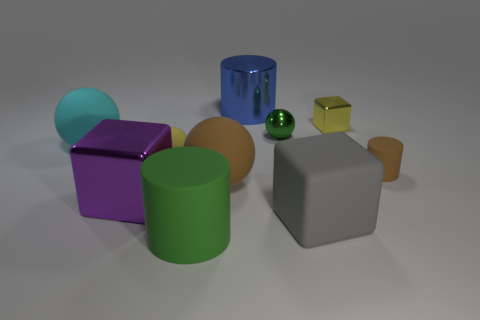Does the small metal sphere have the same color as the large cube on the left side of the blue metallic cylinder?
Offer a very short reply. No. Are there the same number of tiny yellow rubber objects that are right of the big blue object and brown rubber cylinders on the left side of the small green metallic ball?
Give a very brief answer. Yes. There is a block that is left of the gray block; what is its material?
Ensure brevity in your answer.  Metal. What number of objects are tiny cylinders to the right of the purple cube or big gray cylinders?
Your answer should be very brief. 1. What number of other things are there of the same shape as the big brown thing?
Keep it short and to the point. 3. Is the shape of the brown rubber thing that is right of the shiny cylinder the same as  the big purple metal object?
Offer a terse response. No. There is a large purple block; are there any tiny things in front of it?
Make the answer very short. No. How many small objects are either brown rubber cylinders or purple cubes?
Keep it short and to the point. 1. Do the tiny yellow block and the large cyan object have the same material?
Your answer should be compact. No. There is a ball that is the same color as the large matte cylinder; what is its size?
Your answer should be compact. Small. 